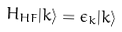Convert formula to latex. <formula><loc_0><loc_0><loc_500><loc_500>H _ { H F } | k \rangle = \epsilon _ { k } | k \rangle</formula> 